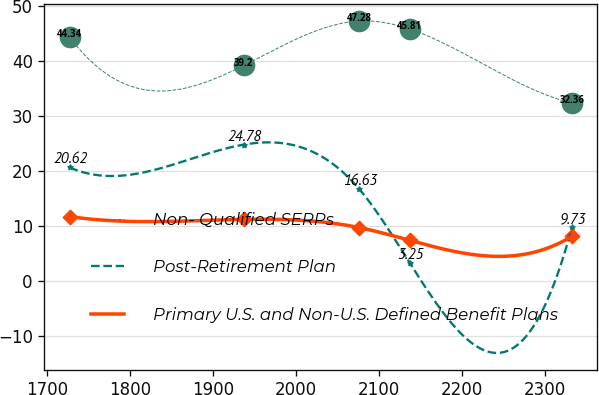<chart> <loc_0><loc_0><loc_500><loc_500><line_chart><ecel><fcel>Non- Qualified SERPs<fcel>Post-Retirement Plan<fcel>Primary U.S. and Non-U.S. Defined Benefit Plans<nl><fcel>1727.39<fcel>44.34<fcel>20.62<fcel>11.68<nl><fcel>1937.45<fcel>39.2<fcel>24.78<fcel>11.16<nl><fcel>2076.87<fcel>47.28<fcel>16.63<fcel>9.66<nl><fcel>2137.43<fcel>45.81<fcel>3.25<fcel>7.35<nl><fcel>2333.03<fcel>32.36<fcel>9.73<fcel>8.08<nl></chart> 